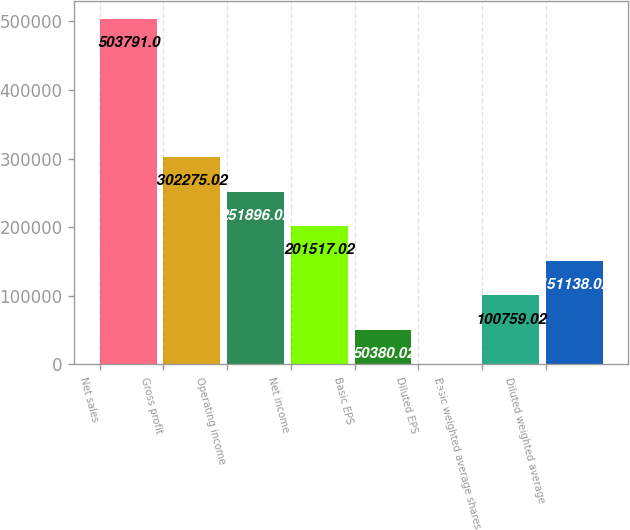<chart> <loc_0><loc_0><loc_500><loc_500><bar_chart><fcel>Net sales<fcel>Gross profit<fcel>Operating income<fcel>Net income<fcel>Basic EPS<fcel>Diluted EPS<fcel>Basic weighted average shares<fcel>Diluted weighted average<nl><fcel>503791<fcel>302275<fcel>251896<fcel>201517<fcel>50380<fcel>1.02<fcel>100759<fcel>151138<nl></chart> 